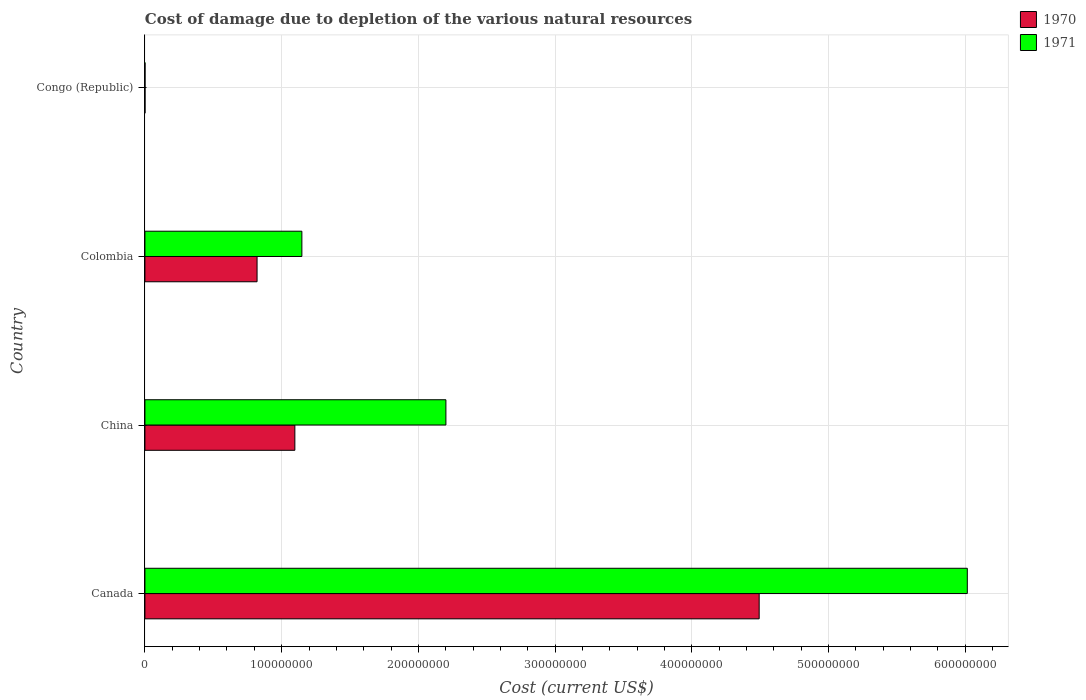Are the number of bars on each tick of the Y-axis equal?
Ensure brevity in your answer.  Yes. How many bars are there on the 1st tick from the top?
Provide a short and direct response. 2. What is the label of the 3rd group of bars from the top?
Your response must be concise. China. What is the cost of damage caused due to the depletion of various natural resources in 1970 in China?
Keep it short and to the point. 1.10e+08. Across all countries, what is the maximum cost of damage caused due to the depletion of various natural resources in 1971?
Make the answer very short. 6.01e+08. Across all countries, what is the minimum cost of damage caused due to the depletion of various natural resources in 1970?
Your answer should be compact. 6.34e+04. In which country was the cost of damage caused due to the depletion of various natural resources in 1971 maximum?
Offer a very short reply. Canada. In which country was the cost of damage caused due to the depletion of various natural resources in 1971 minimum?
Offer a very short reply. Congo (Republic). What is the total cost of damage caused due to the depletion of various natural resources in 1970 in the graph?
Your response must be concise. 6.41e+08. What is the difference between the cost of damage caused due to the depletion of various natural resources in 1971 in China and that in Congo (Republic)?
Give a very brief answer. 2.20e+08. What is the difference between the cost of damage caused due to the depletion of various natural resources in 1970 in China and the cost of damage caused due to the depletion of various natural resources in 1971 in Congo (Republic)?
Give a very brief answer. 1.10e+08. What is the average cost of damage caused due to the depletion of various natural resources in 1971 per country?
Your response must be concise. 2.34e+08. What is the difference between the cost of damage caused due to the depletion of various natural resources in 1971 and cost of damage caused due to the depletion of various natural resources in 1970 in Congo (Republic)?
Your answer should be very brief. 1.00e+04. In how many countries, is the cost of damage caused due to the depletion of various natural resources in 1971 greater than 440000000 US$?
Ensure brevity in your answer.  1. What is the ratio of the cost of damage caused due to the depletion of various natural resources in 1970 in China to that in Colombia?
Offer a very short reply. 1.34. Is the difference between the cost of damage caused due to the depletion of various natural resources in 1971 in Canada and China greater than the difference between the cost of damage caused due to the depletion of various natural resources in 1970 in Canada and China?
Make the answer very short. Yes. What is the difference between the highest and the second highest cost of damage caused due to the depletion of various natural resources in 1970?
Your answer should be compact. 3.40e+08. What is the difference between the highest and the lowest cost of damage caused due to the depletion of various natural resources in 1971?
Provide a short and direct response. 6.01e+08. In how many countries, is the cost of damage caused due to the depletion of various natural resources in 1970 greater than the average cost of damage caused due to the depletion of various natural resources in 1970 taken over all countries?
Give a very brief answer. 1. Is the sum of the cost of damage caused due to the depletion of various natural resources in 1970 in China and Colombia greater than the maximum cost of damage caused due to the depletion of various natural resources in 1971 across all countries?
Provide a short and direct response. No. What does the 1st bar from the bottom in Congo (Republic) represents?
Offer a terse response. 1970. How many bars are there?
Ensure brevity in your answer.  8. How many countries are there in the graph?
Your response must be concise. 4. What is the difference between two consecutive major ticks on the X-axis?
Keep it short and to the point. 1.00e+08. Does the graph contain grids?
Give a very brief answer. Yes. How many legend labels are there?
Make the answer very short. 2. What is the title of the graph?
Ensure brevity in your answer.  Cost of damage due to depletion of the various natural resources. What is the label or title of the X-axis?
Keep it short and to the point. Cost (current US$). What is the Cost (current US$) of 1970 in Canada?
Your answer should be very brief. 4.49e+08. What is the Cost (current US$) of 1971 in Canada?
Offer a terse response. 6.01e+08. What is the Cost (current US$) of 1970 in China?
Make the answer very short. 1.10e+08. What is the Cost (current US$) in 1971 in China?
Your response must be concise. 2.20e+08. What is the Cost (current US$) in 1970 in Colombia?
Offer a very short reply. 8.20e+07. What is the Cost (current US$) in 1971 in Colombia?
Give a very brief answer. 1.15e+08. What is the Cost (current US$) in 1970 in Congo (Republic)?
Provide a short and direct response. 6.34e+04. What is the Cost (current US$) in 1971 in Congo (Republic)?
Give a very brief answer. 7.34e+04. Across all countries, what is the maximum Cost (current US$) of 1970?
Your answer should be compact. 4.49e+08. Across all countries, what is the maximum Cost (current US$) of 1971?
Keep it short and to the point. 6.01e+08. Across all countries, what is the minimum Cost (current US$) of 1970?
Your answer should be very brief. 6.34e+04. Across all countries, what is the minimum Cost (current US$) of 1971?
Give a very brief answer. 7.34e+04. What is the total Cost (current US$) of 1970 in the graph?
Provide a short and direct response. 6.41e+08. What is the total Cost (current US$) in 1971 in the graph?
Make the answer very short. 9.36e+08. What is the difference between the Cost (current US$) of 1970 in Canada and that in China?
Make the answer very short. 3.40e+08. What is the difference between the Cost (current US$) of 1971 in Canada and that in China?
Keep it short and to the point. 3.81e+08. What is the difference between the Cost (current US$) of 1970 in Canada and that in Colombia?
Offer a terse response. 3.67e+08. What is the difference between the Cost (current US$) in 1971 in Canada and that in Colombia?
Provide a succinct answer. 4.87e+08. What is the difference between the Cost (current US$) of 1970 in Canada and that in Congo (Republic)?
Your answer should be very brief. 4.49e+08. What is the difference between the Cost (current US$) of 1971 in Canada and that in Congo (Republic)?
Your answer should be very brief. 6.01e+08. What is the difference between the Cost (current US$) of 1970 in China and that in Colombia?
Your answer should be compact. 2.76e+07. What is the difference between the Cost (current US$) in 1971 in China and that in Colombia?
Your answer should be compact. 1.05e+08. What is the difference between the Cost (current US$) in 1970 in China and that in Congo (Republic)?
Provide a short and direct response. 1.10e+08. What is the difference between the Cost (current US$) in 1971 in China and that in Congo (Republic)?
Make the answer very short. 2.20e+08. What is the difference between the Cost (current US$) in 1970 in Colombia and that in Congo (Republic)?
Your answer should be very brief. 8.20e+07. What is the difference between the Cost (current US$) of 1971 in Colombia and that in Congo (Republic)?
Your answer should be compact. 1.15e+08. What is the difference between the Cost (current US$) in 1970 in Canada and the Cost (current US$) in 1971 in China?
Offer a terse response. 2.29e+08. What is the difference between the Cost (current US$) in 1970 in Canada and the Cost (current US$) in 1971 in Colombia?
Your response must be concise. 3.34e+08. What is the difference between the Cost (current US$) in 1970 in Canada and the Cost (current US$) in 1971 in Congo (Republic)?
Provide a short and direct response. 4.49e+08. What is the difference between the Cost (current US$) in 1970 in China and the Cost (current US$) in 1971 in Colombia?
Ensure brevity in your answer.  -5.13e+06. What is the difference between the Cost (current US$) of 1970 in China and the Cost (current US$) of 1971 in Congo (Republic)?
Your answer should be very brief. 1.10e+08. What is the difference between the Cost (current US$) in 1970 in Colombia and the Cost (current US$) in 1971 in Congo (Republic)?
Your answer should be very brief. 8.19e+07. What is the average Cost (current US$) in 1970 per country?
Your answer should be compact. 1.60e+08. What is the average Cost (current US$) in 1971 per country?
Provide a short and direct response. 2.34e+08. What is the difference between the Cost (current US$) in 1970 and Cost (current US$) in 1971 in Canada?
Make the answer very short. -1.52e+08. What is the difference between the Cost (current US$) in 1970 and Cost (current US$) in 1971 in China?
Give a very brief answer. -1.10e+08. What is the difference between the Cost (current US$) in 1970 and Cost (current US$) in 1971 in Colombia?
Provide a succinct answer. -3.28e+07. What is the difference between the Cost (current US$) in 1970 and Cost (current US$) in 1971 in Congo (Republic)?
Your response must be concise. -1.00e+04. What is the ratio of the Cost (current US$) of 1970 in Canada to that in China?
Offer a very short reply. 4.1. What is the ratio of the Cost (current US$) of 1971 in Canada to that in China?
Ensure brevity in your answer.  2.73. What is the ratio of the Cost (current US$) of 1970 in Canada to that in Colombia?
Your response must be concise. 5.48. What is the ratio of the Cost (current US$) of 1971 in Canada to that in Colombia?
Provide a short and direct response. 5.24. What is the ratio of the Cost (current US$) of 1970 in Canada to that in Congo (Republic)?
Offer a terse response. 7082.81. What is the ratio of the Cost (current US$) of 1971 in Canada to that in Congo (Republic)?
Offer a very short reply. 8189.46. What is the ratio of the Cost (current US$) in 1970 in China to that in Colombia?
Make the answer very short. 1.34. What is the ratio of the Cost (current US$) in 1971 in China to that in Colombia?
Give a very brief answer. 1.92. What is the ratio of the Cost (current US$) in 1970 in China to that in Congo (Republic)?
Offer a very short reply. 1728.88. What is the ratio of the Cost (current US$) in 1971 in China to that in Congo (Republic)?
Offer a terse response. 2997.27. What is the ratio of the Cost (current US$) in 1970 in Colombia to that in Congo (Republic)?
Keep it short and to the point. 1293.18. What is the ratio of the Cost (current US$) of 1971 in Colombia to that in Congo (Republic)?
Provide a short and direct response. 1562.98. What is the difference between the highest and the second highest Cost (current US$) of 1970?
Your response must be concise. 3.40e+08. What is the difference between the highest and the second highest Cost (current US$) in 1971?
Offer a terse response. 3.81e+08. What is the difference between the highest and the lowest Cost (current US$) in 1970?
Provide a succinct answer. 4.49e+08. What is the difference between the highest and the lowest Cost (current US$) in 1971?
Your response must be concise. 6.01e+08. 